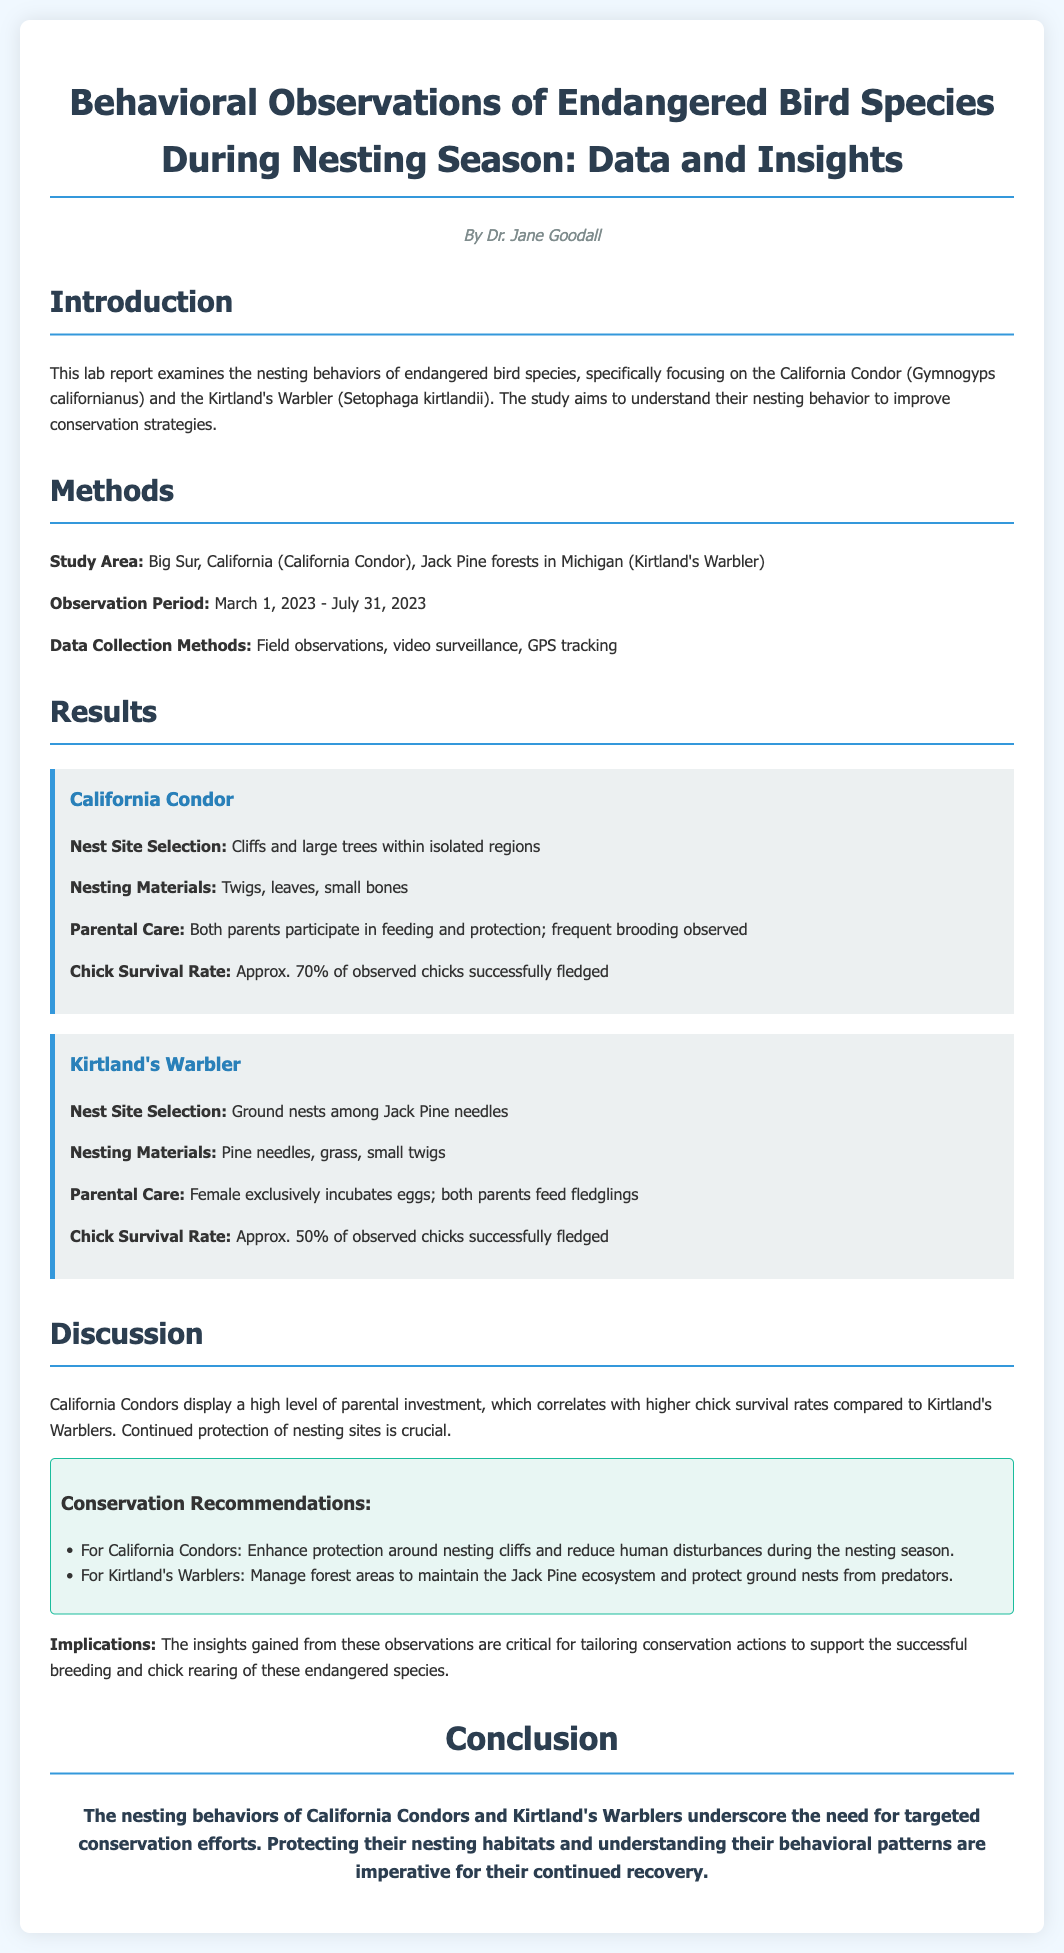what are the two endangered bird species studied? The introduced document discusses two specific endangered bird species: the California Condor and the Kirtland's Warbler.
Answer: California Condor, Kirtland's Warbler what is the observation period for this study? The observation period, during which data was collected, is stated as March 1, 2023 - July 31, 2023.
Answer: March 1, 2023 - July 31, 2023 what materials do California Condors use for nesting? The document lists the nesting materials used by California Condors, which include twigs, leaves, and small bones.
Answer: Twigs, leaves, small bones what is the chick survival rate for Kirtland's Warblers? The report mentions the chick survival rate for Kirtland's Warblers is approximately 50% based on observations.
Answer: Approx. 50% which parental behavior differs significantly between the two species? The document highlights that in Kirtland's Warblers, only the female incubates the eggs, contrasting with the California Condors, where both parents participate in care.
Answer: Female exclusively incubates what are the recommended conservation measures for California Condors? The recommendations for California Condors include enhancing protection around nesting cliffs and reducing human disturbances during the nesting season.
Answer: Enhance protection around nesting cliffs what type of ecosystems does the Kirtland's Warbler's nesting depend on? The Kirtland's Warbler nests depend specifically on Jack Pine forests, as indicated in the methods section of the report.
Answer: Jack Pine forests what is the main implication of the observations made in the study? The document states that the insights gained from observations are crucial for tailoring conservation actions needed for supporting endangered species.
Answer: Tailoring conservation actions 